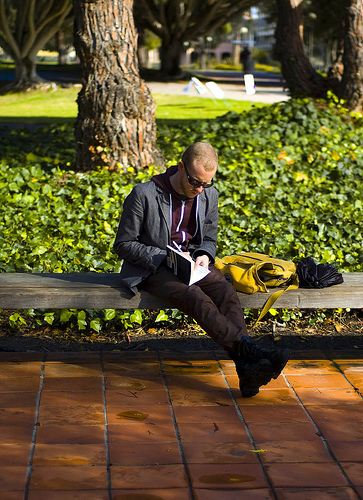<image>
Is there a tree to the left of the bench? No. The tree is not to the left of the bench. From this viewpoint, they have a different horizontal relationship. Is the man behind the plant? No. The man is not behind the plant. From this viewpoint, the man appears to be positioned elsewhere in the scene. 